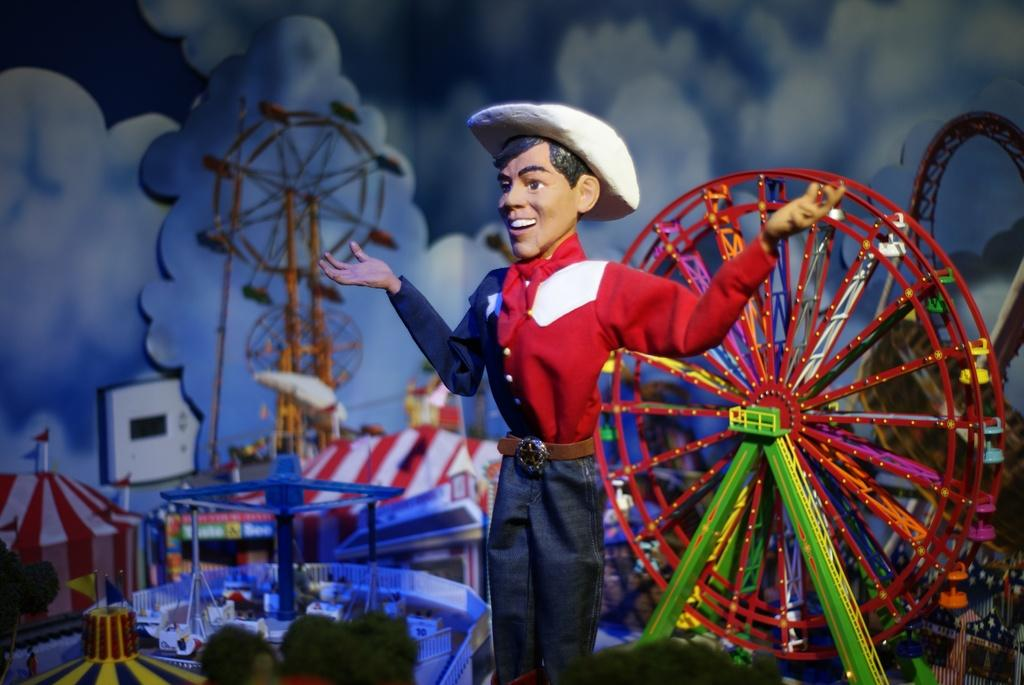What style is the image drawn in? The image is a cartoon. Who is present in the image? There is a man in the image. What activities are depicted in the image? There are recreation games in the image. What can be seen in the sky in the image? Clouds are visible in the image. What type of mask is the man wearing in the image? There is no mask present in the image; it is a cartoon featuring a man without any masks. How much sugar is visible in the image? There is no sugar present in the image; it is a cartoon featuring a man and recreation games, not food items. 